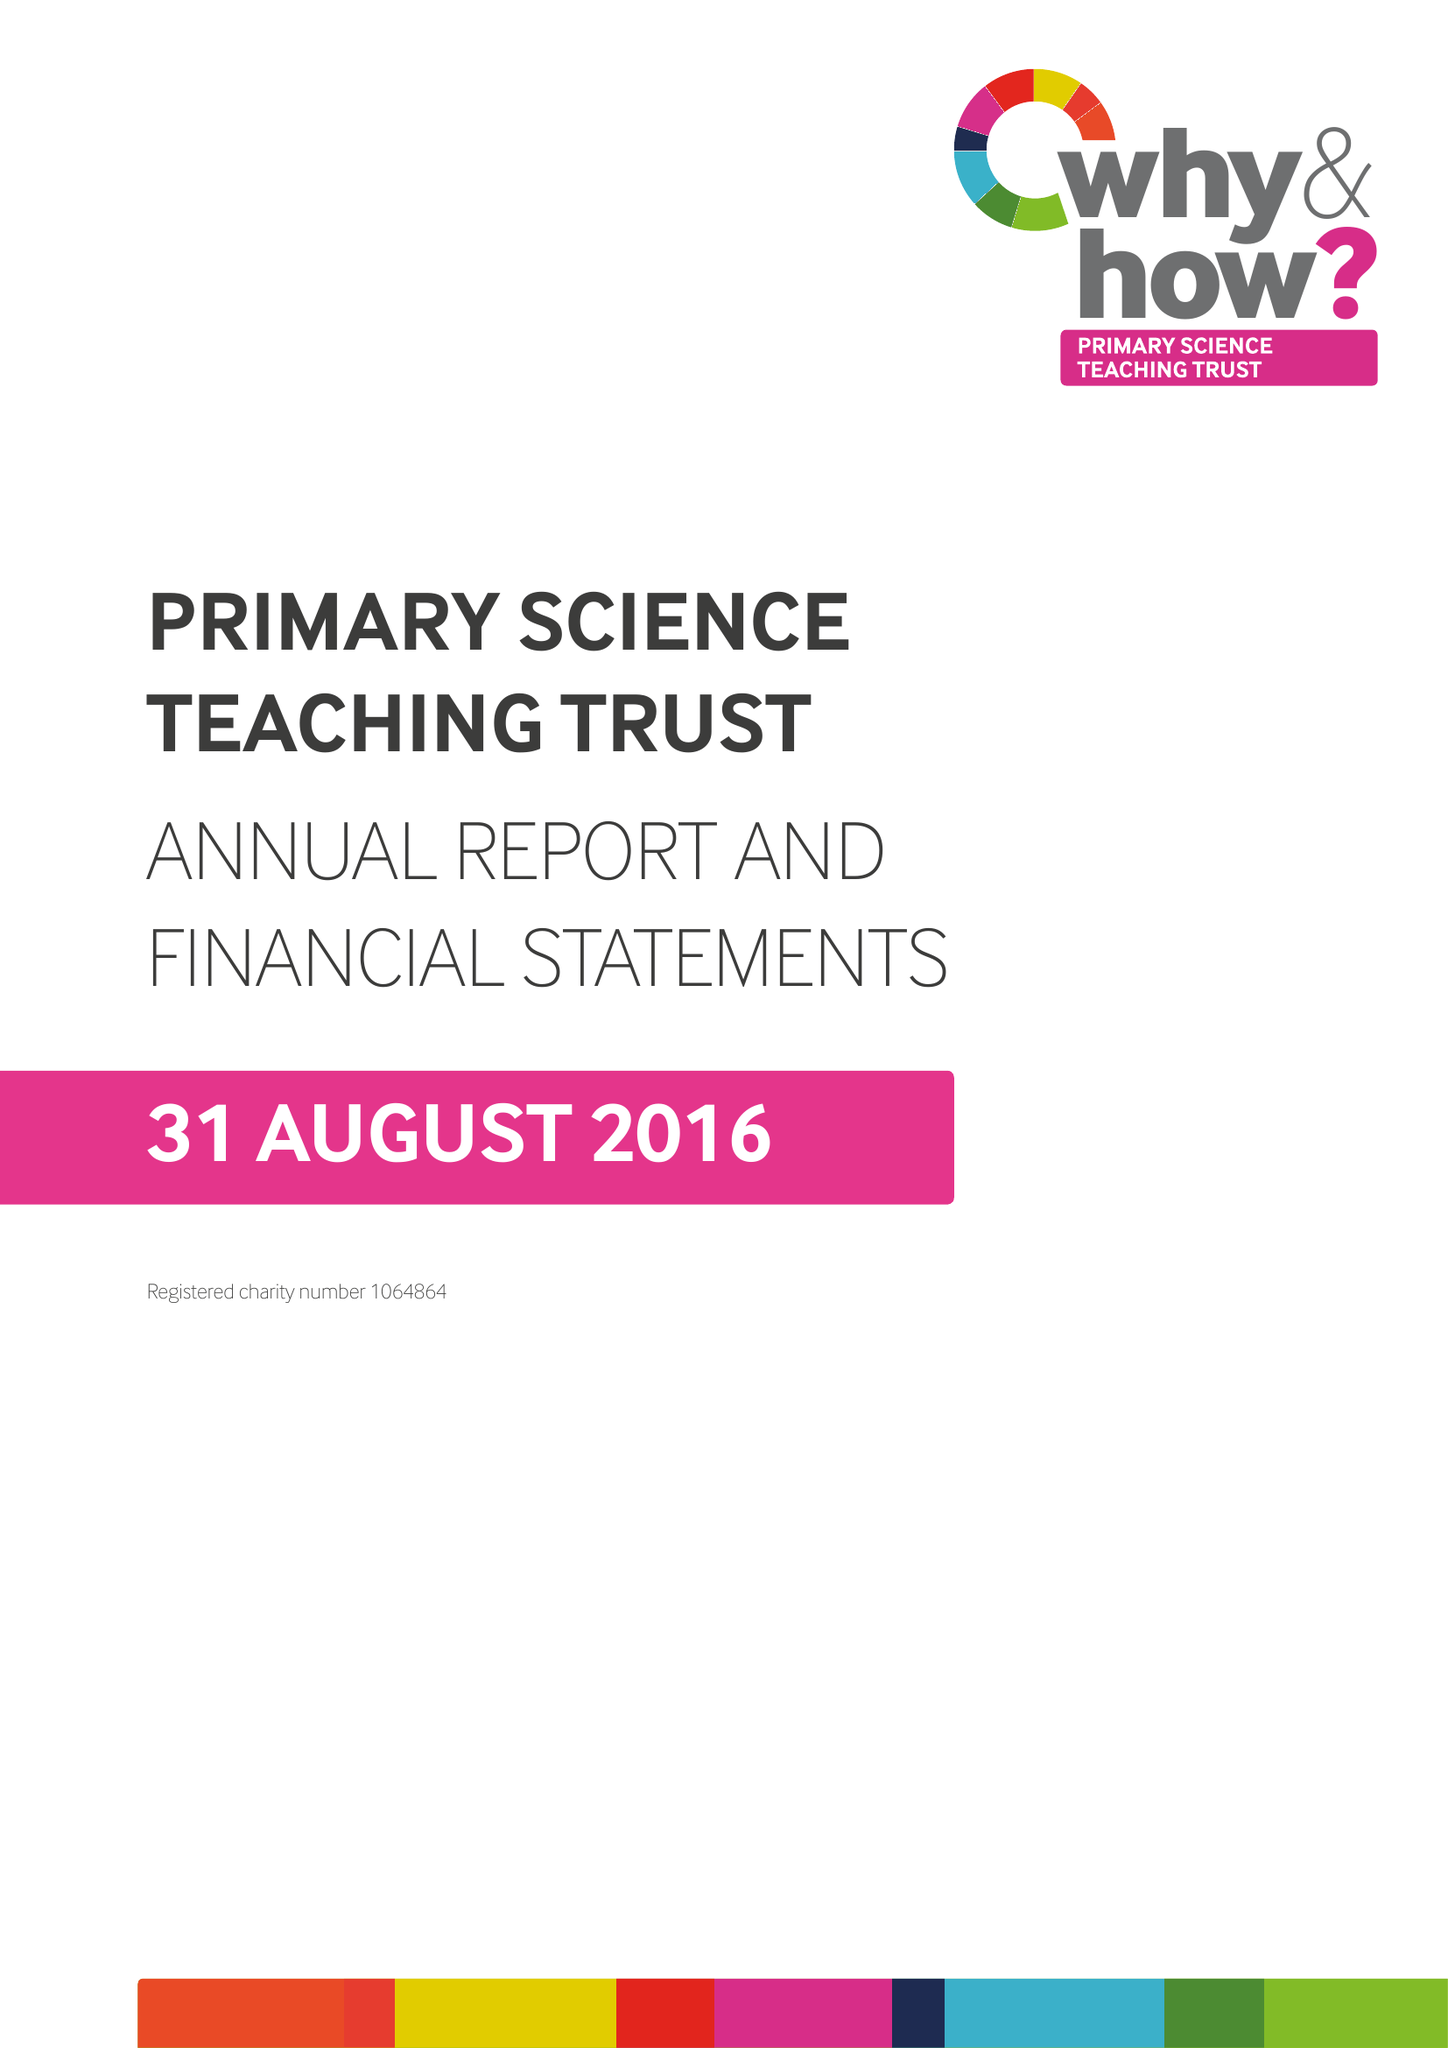What is the value for the address__postcode?
Answer the question using a single word or phrase. BS8 1PD 